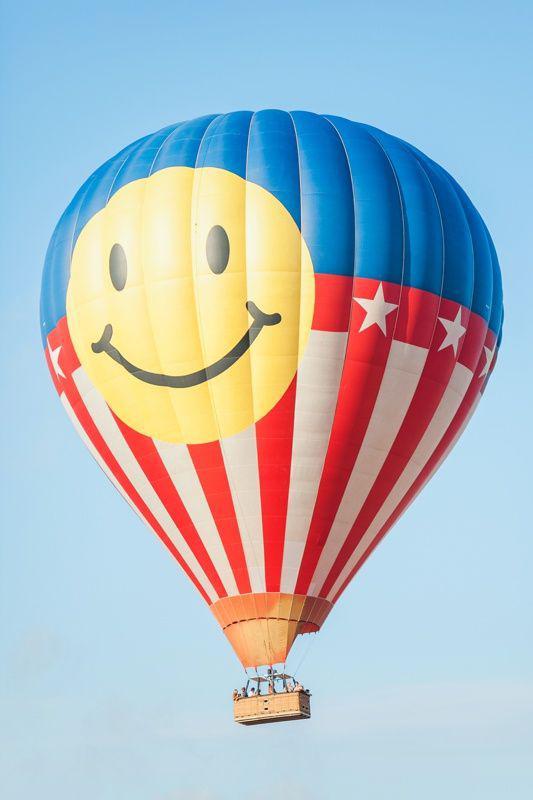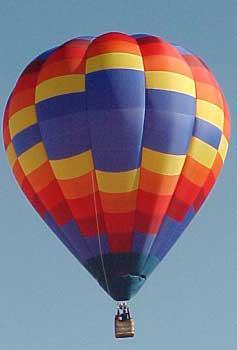The first image is the image on the left, the second image is the image on the right. Considering the images on both sides, is "There are exactly 2 flying balloons." valid? Answer yes or no. Yes. The first image is the image on the left, the second image is the image on the right. For the images displayed, is the sentence "In total, two hot-air balloons are shown, each floating in the air." factually correct? Answer yes or no. Yes. 